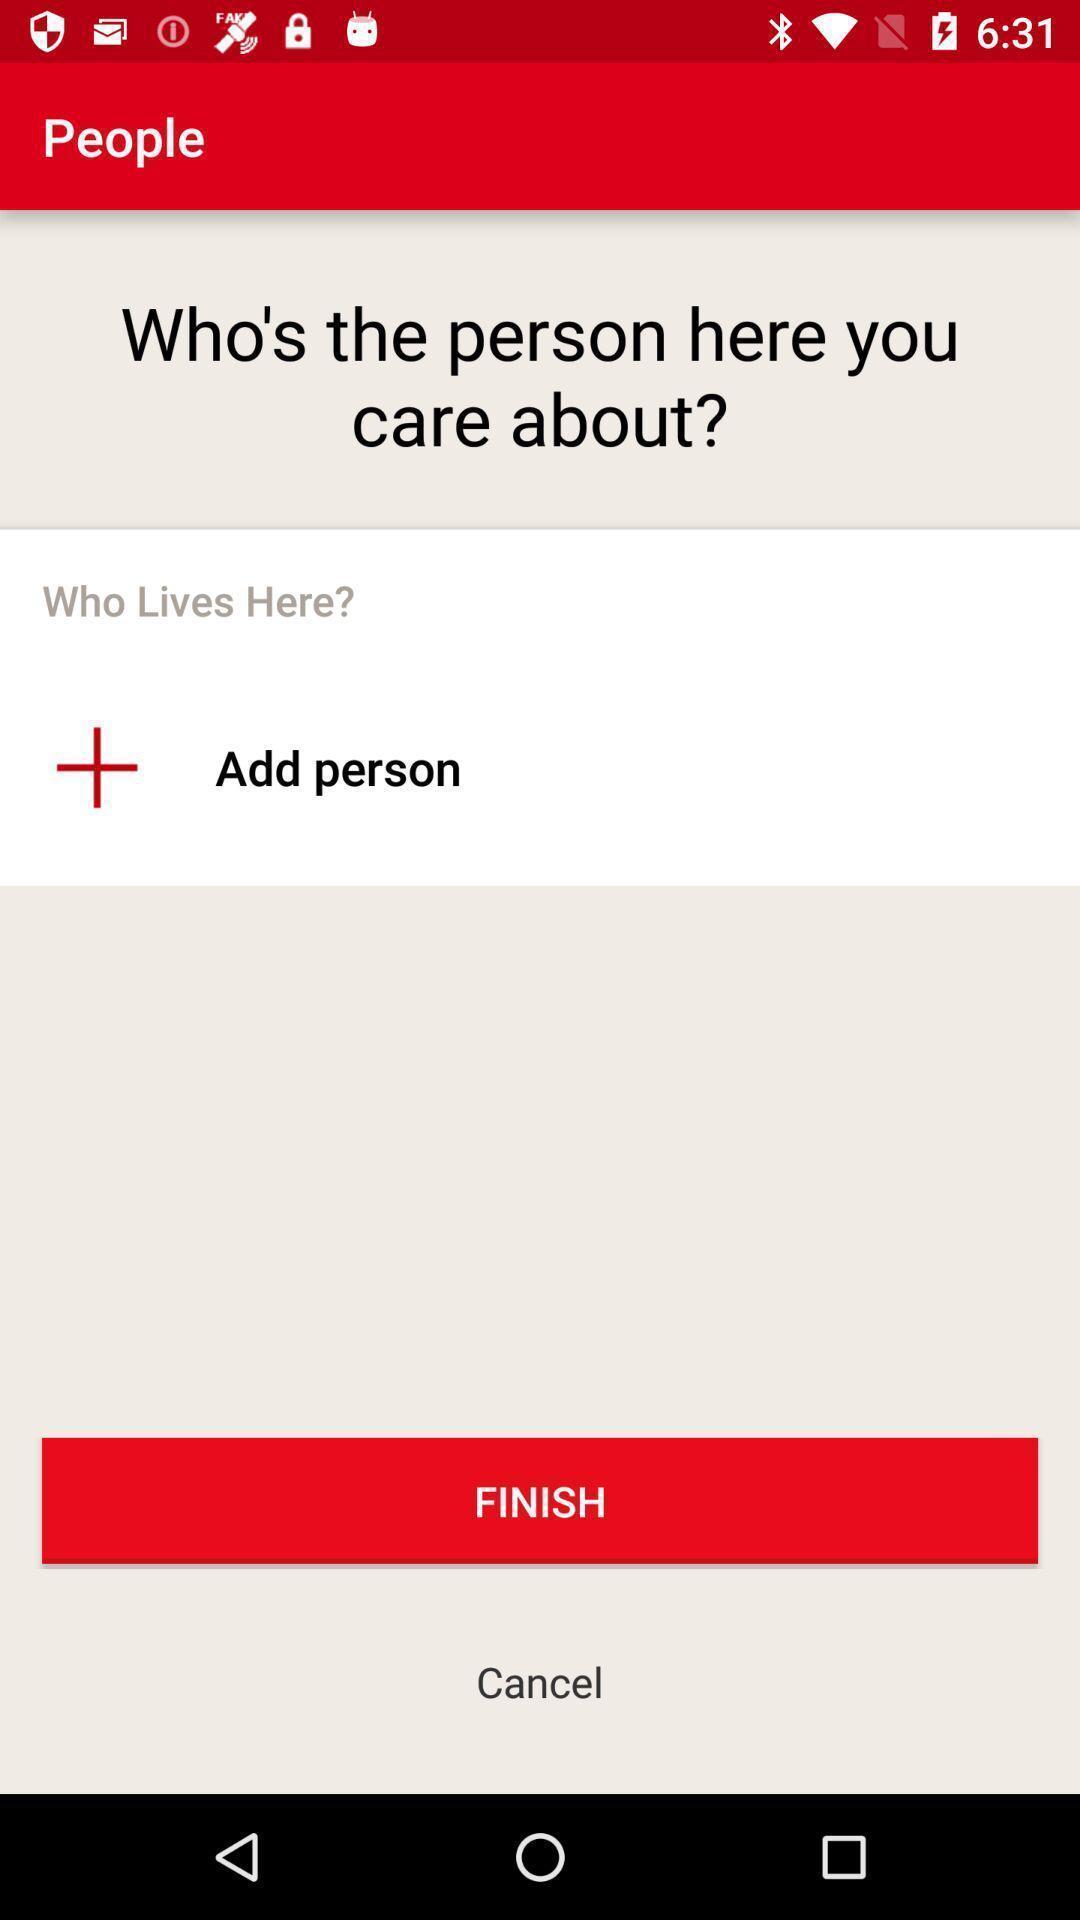Give me a summary of this screen capture. Page to add a person. 